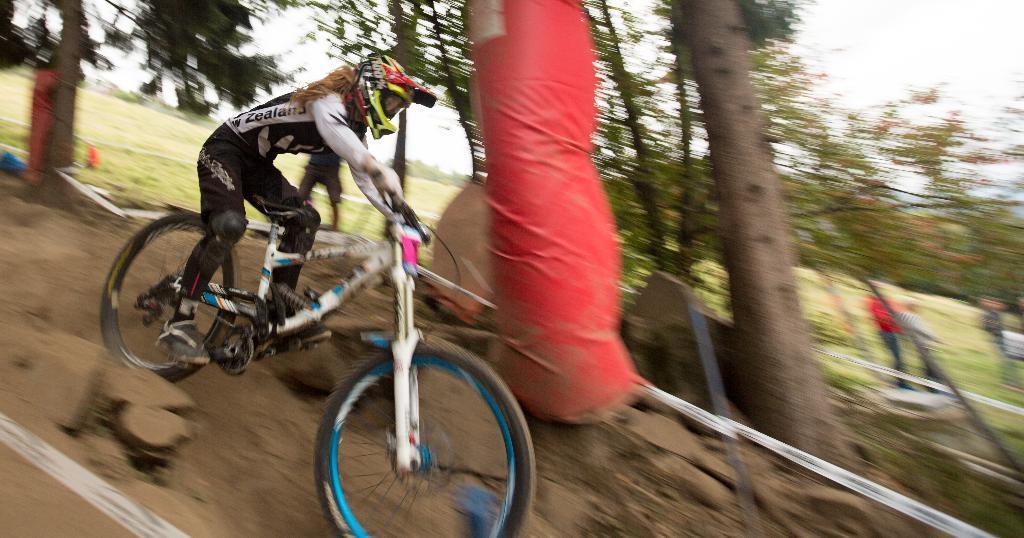Please provide a concise description of this image. In this picture we can see a woman wore a helmet, shoes and riding a bicycle on the ground, trees and some people standing and in the background we can see the sky. 